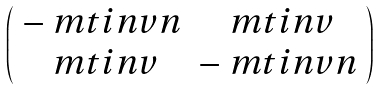Convert formula to latex. <formula><loc_0><loc_0><loc_500><loc_500>\left ( \begin{array} { c c } - \ m t i n v n & \ m t i n v \\ \ m t i n v & - \ m t i n v n \end{array} \right )</formula> 